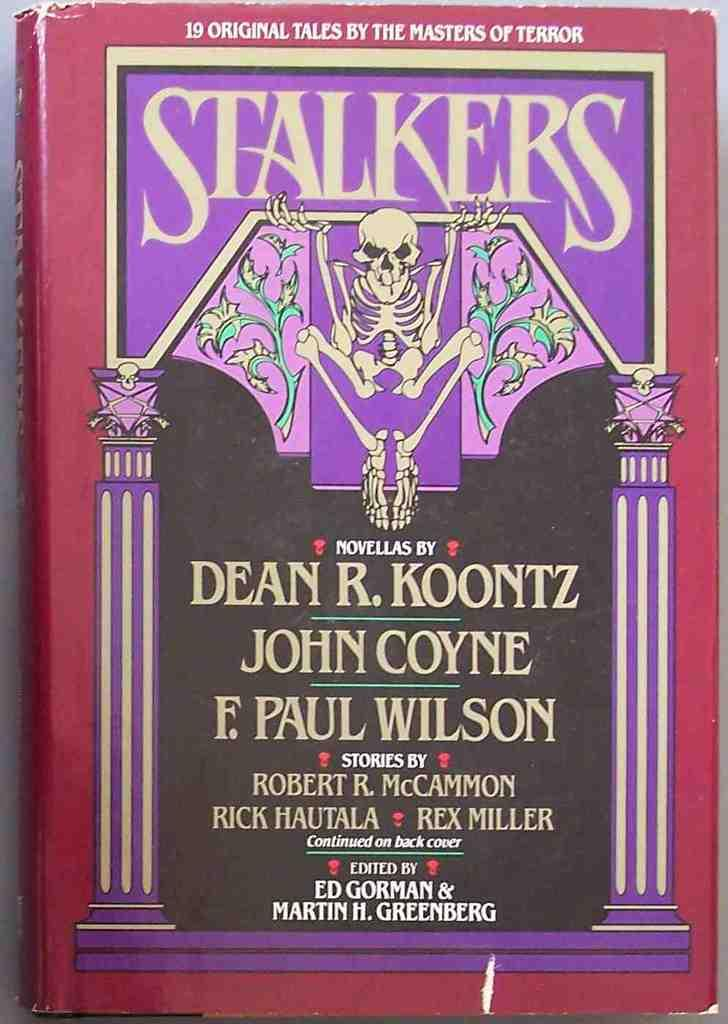<image>
Offer a succinct explanation of the picture presented. a book that has the title 'stalkers' on the top 